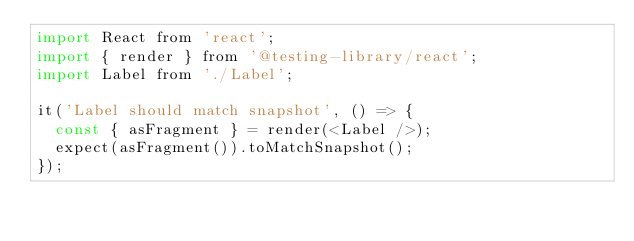<code> <loc_0><loc_0><loc_500><loc_500><_JavaScript_>import React from 'react';
import { render } from '@testing-library/react';
import Label from './Label';

it('Label should match snapshot', () => {
  const { asFragment } = render(<Label />);
  expect(asFragment()).toMatchSnapshot();
});
</code> 